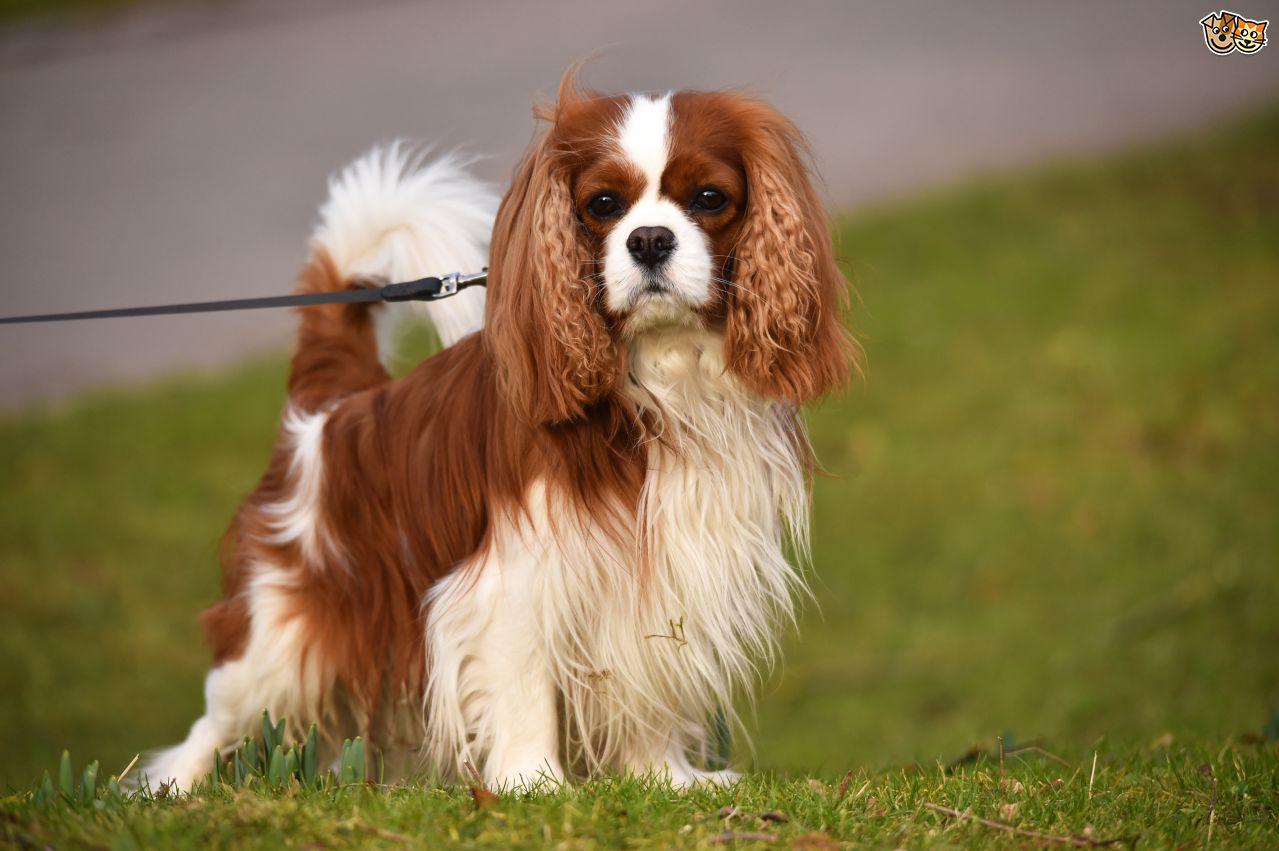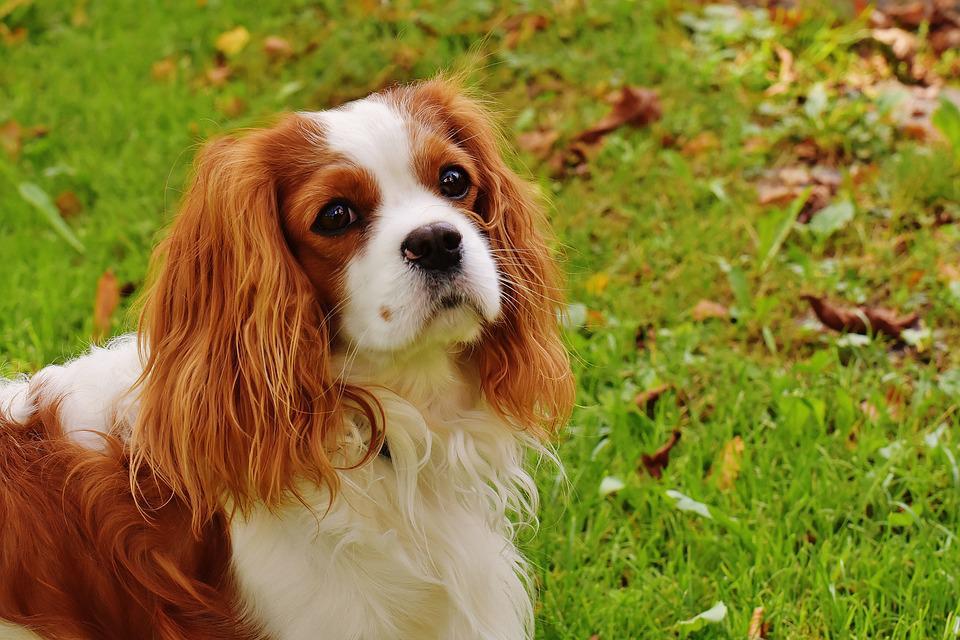The first image is the image on the left, the second image is the image on the right. For the images displayed, is the sentence "You can clearly see at least one dogs leg, unobstructed by hanging fur." factually correct? Answer yes or no. Yes. The first image is the image on the left, the second image is the image on the right. For the images shown, is this caption "The spaniel in the left image is in a forward sitting position outdoors." true? Answer yes or no. No. 